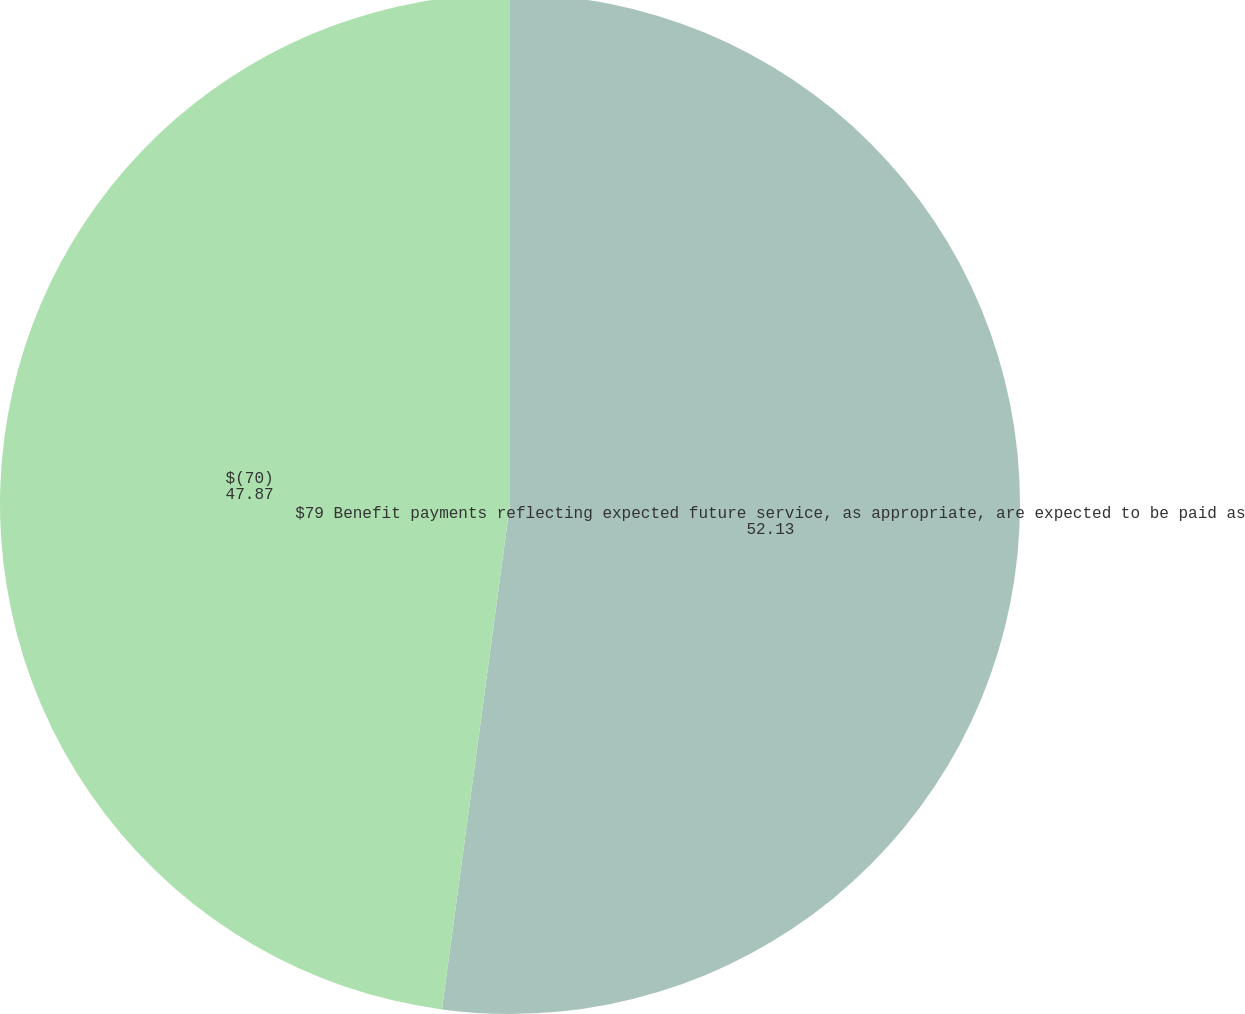Convert chart to OTSL. <chart><loc_0><loc_0><loc_500><loc_500><pie_chart><fcel>$79 Benefit payments reflecting expected future service, as appropriate, are expected to be paid as<fcel>$(70)<nl><fcel>52.13%<fcel>47.87%<nl></chart> 